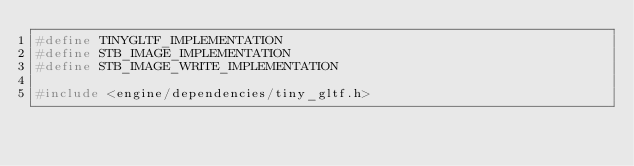<code> <loc_0><loc_0><loc_500><loc_500><_C++_>#define TINYGLTF_IMPLEMENTATION
#define STB_IMAGE_IMPLEMENTATION
#define STB_IMAGE_WRITE_IMPLEMENTATION

#include <engine/dependencies/tiny_gltf.h></code> 